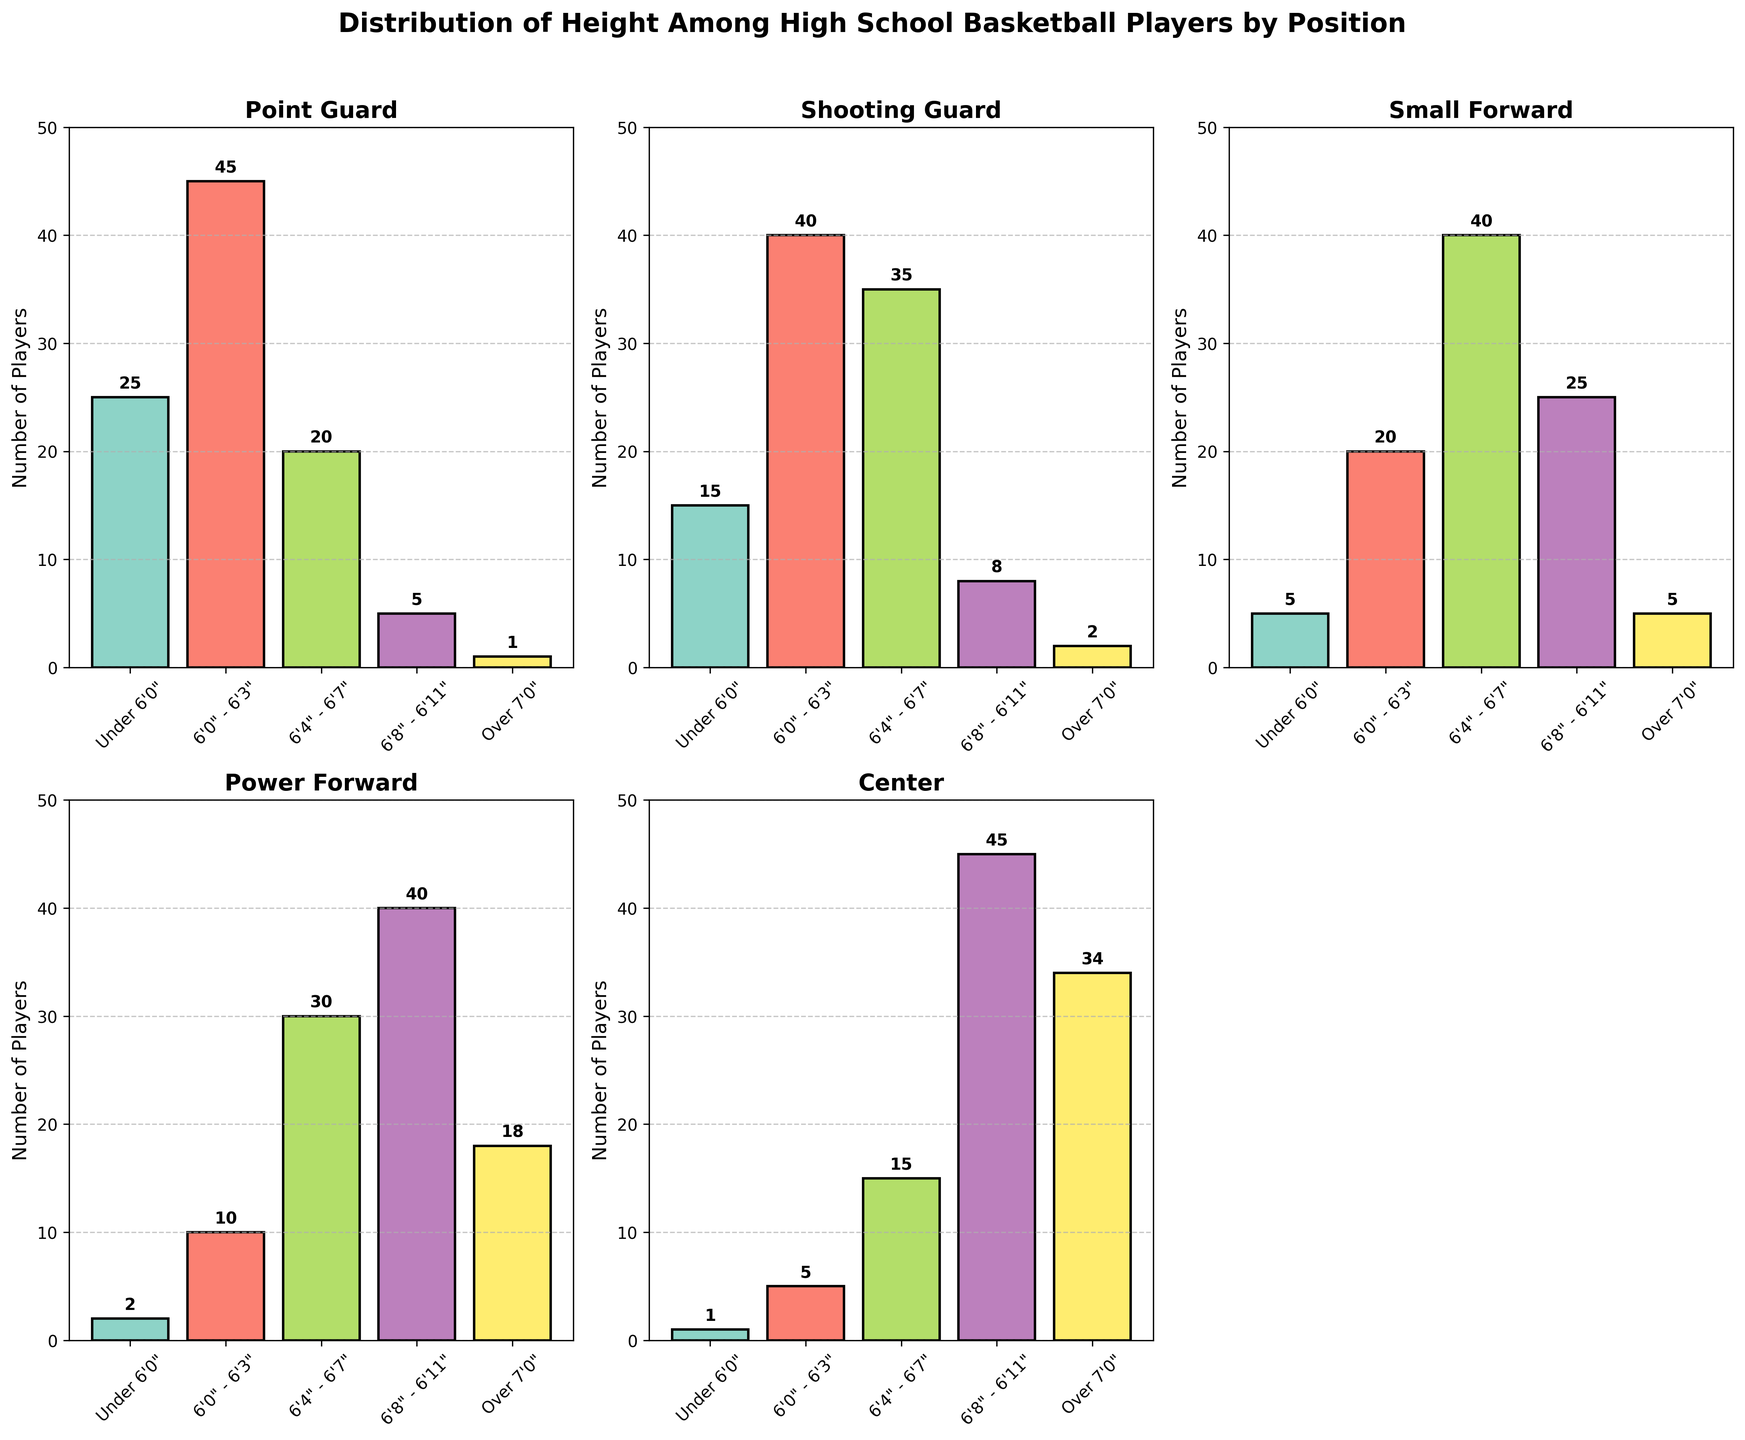What is the title of the figure? The title is located at the top of the figure.
Answer: Distribution of Height Among High School Basketball Players by Position Which position has the highest number of players under 6'0"? Look at the bars representing the 'Under 6'0"' height range and identify the tallest bar. The position with the highest bar has the most players.
Answer: Point Guard How many players are there over 7'0" in the center position? Find the bar representing the 'Over 7'0"' height range in the subplot for the center position. Read the label on top of the bar.
Answer: 34 What is the total number of players in the 6'8" - 6'11" height range across all positions? Sum the heights of the bars in the 6'8" - 6'11" height range from each subplot.
Answer: 123 What is the difference in the number of players 6'0" - 6'3" between Point Guards and Small Forwards? Subtract the number of players in the 6'0" - 6'3" range for Small Forwards from the number for Point Guards.
Answer: 25 Which height range has the most players in the Shooting Guard position? Identify the tallest bar in the Shooting Guard subplot and note the corresponding height range on the x-axis.
Answer: 6'0" - 6'3" How many more players are there that are 6'4" - 6'7" in the Power Forward position compared to the Point Guard position? Subtract the number of players in the 6'4" - 6'7" height range for Point Guards from the number for Power Forwards.
Answer: 10 Which position has the lowest number of players in the 6'8" - 6'11" height range? Identify the shortest bar in the 6'8" - 6'11" height range across all subplots. Note the position it belongs to.
Answer: Point Guard Which height range has the smallest number of players across all positions? Compare the total number of players per height range by summing all bars in each height range across all subplots. The height range with the smallest total is the answer.
Answer: Over 7'0" 